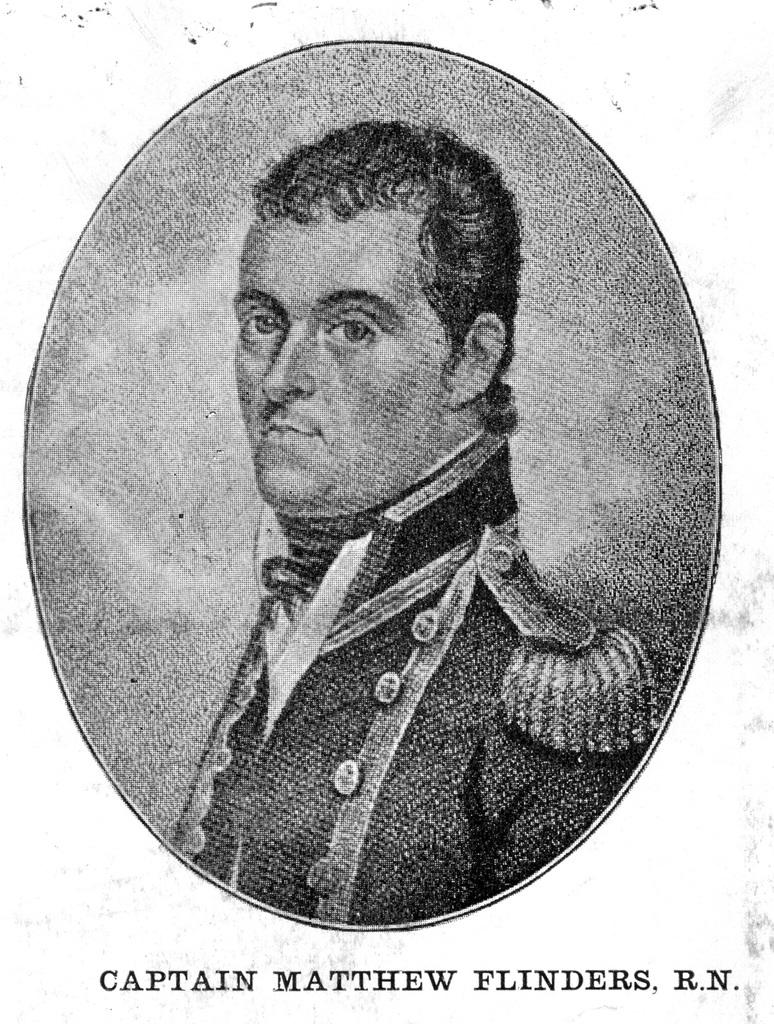What is depicted on the poster in the image? There is a poster of a person in the image. What else can be seen on the poster besides the person? There is text on the poster. What is the color of the background in the image? The background color is white. How many planes are flying in the image? There are no planes visible in the image; it features a poster with a person and text on a white background. What type of knowledge is being shared in the image? The image does not depict any knowledge being shared; it is a poster with a person and text on a white background. 